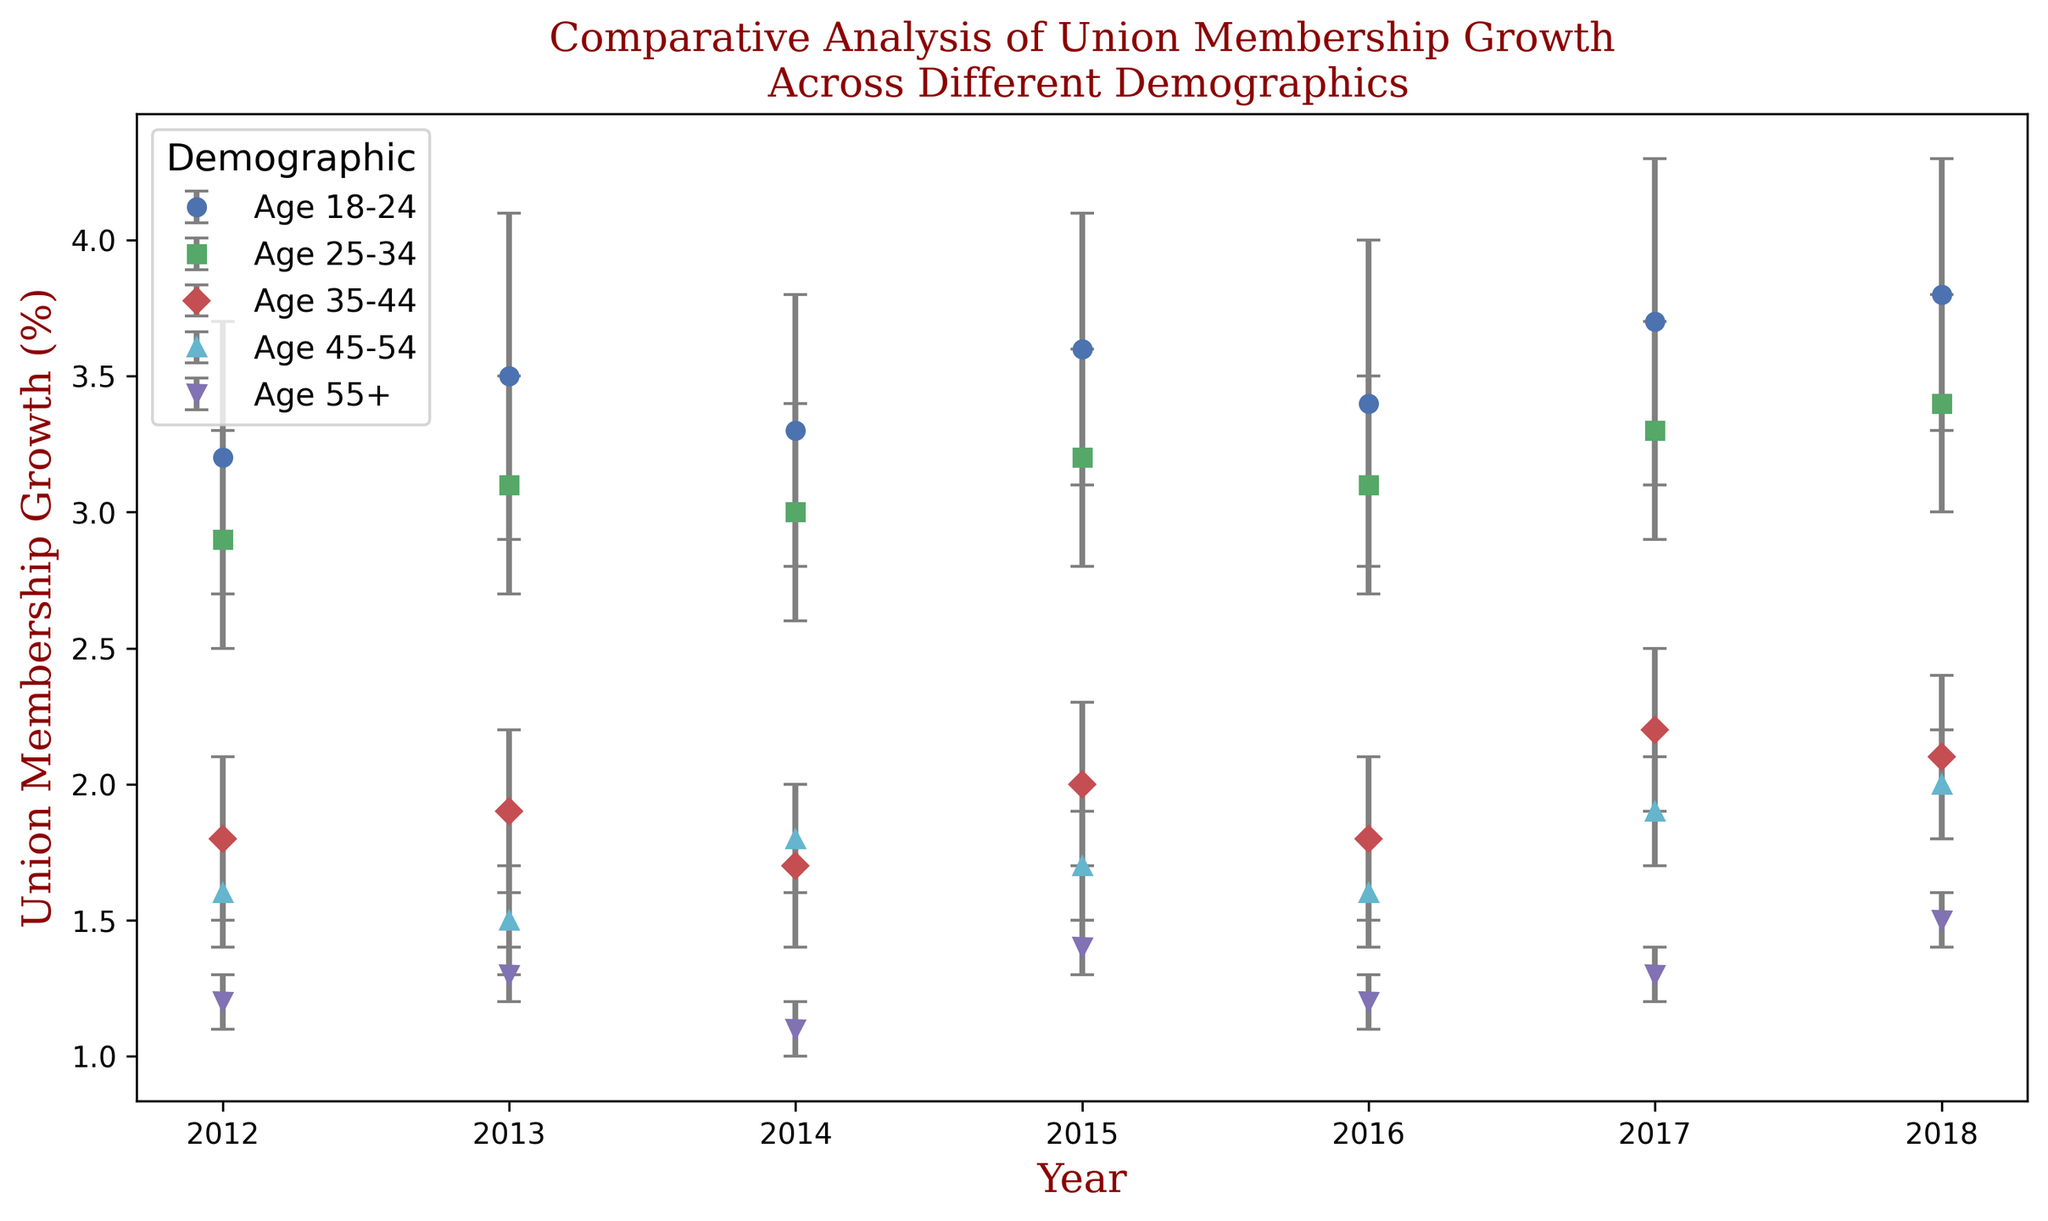Which demographic had the highest union membership growth in 2018? To find the answer, look at the figures for 2018 and compare the union membership growth rates for each demographic. The highest value is 3.8%, which belongs to the Age 18-24 group.
Answer: Age 18-24 What is the difference in union membership growth between Age 45-54 and Age 35-44 in 2017? In 2017, the union membership growth for Age 45-54 is 1.9%, and for Age 35-44, it is 2.2%. The difference is calculated as 2.2% - 1.9% = 0.3%.
Answer: 0.3% Which demographic showed the least amount of growth uncertainty in 2012? To determine this, compare the error ranges for each demographic in 2012. The smallest error range is 0.1%, which belongs to the Age 55+ group.
Answer: Age 55+ How did union membership growth for Age 18-24 change from 2012 to 2016? Union membership growth for Age 18-24 was 3.2% in 2012 and rose to 3.4% in 2016. The change is calculated as 3.4% - 3.2% = 0.2%.
Answer: Increased by 0.2% What’s the average union membership growth for Age 25-34 from 2014 to 2018? Sum the growth values for Age 25-34 from 2014 to 2018 (3.0 + 3.2 + 3.1 + 3.3 + 3.4) = 16.0%. Then divide by the number of years (5): 16.0 / 5 = 3.2%.
Answer: 3.2% Which demographic saw a consistent increase in union membership growth from 2014 to 2018? Review each demographic's growth values from 2014 to 2018. Only the Age 55+ shows a steady increase: 1.1%, 1.4%, 1.2%, 1.3%, 1.5%.
Answer: Age 55+ For which year did Age 45-54 have the largest growth uncertainty, and what was the error range? Examine the error ranges for Age 45-54 across all years. The largest uncertainty is 0.2%, which appears consistently each year.
Answer: Any year (2012-2018) Which demographic has the highest variability in union membership growth as indicated by error ranges over the years? For each demographic, add up the error ranges from 2012 to 2018 and compare the sums. The Age 18-24 group has the highest total error range.
Answer: Age 18-24 What is the sum of union membership growth for Age 35-44 and Age 55+ in 2015? For 2015, add the growth rates for Age 35-44 (2.0%) and Age 55+ (1.4%) to get 2.0 + 1.4 = 3.4%.
Answer: 3.4% What trend can you observe for the Age 25-34 group from 2012 to 2018? Analyze the union membership growth rates for Age 25-34 from 2012 to 2018: 2.9%, 3.1%, 3.0%, 3.2%, 3.1%, 3.3%, 3.4%. There is a general increasing trend over these years.
Answer: Increasing trend 